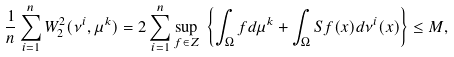<formula> <loc_0><loc_0><loc_500><loc_500>\frac { 1 } { n } \sum _ { i = 1 } ^ { n } W _ { 2 } ^ { 2 } ( \nu ^ { i } , \mu ^ { k } ) & = 2 \sum _ { i = 1 } ^ { n } \underset { f \in Z } { \sup } \ \left \{ \int _ { \Omega } f d \mu ^ { k } + \int _ { \Omega } S f ( x ) d \nu ^ { i } ( x ) \right \} \leq M ,</formula> 